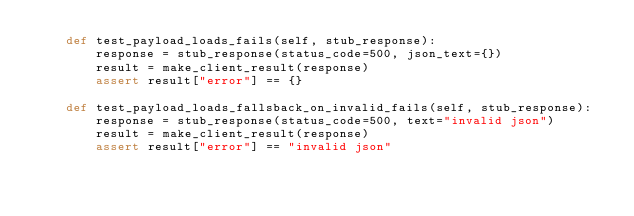<code> <loc_0><loc_0><loc_500><loc_500><_Python_>    def test_payload_loads_fails(self, stub_response):
        response = stub_response(status_code=500, json_text={})
        result = make_client_result(response)
        assert result["error"] == {}

    def test_payload_loads_fallsback_on_invalid_fails(self, stub_response):
        response = stub_response(status_code=500, text="invalid json")
        result = make_client_result(response)
        assert result["error"] == "invalid json"
</code> 